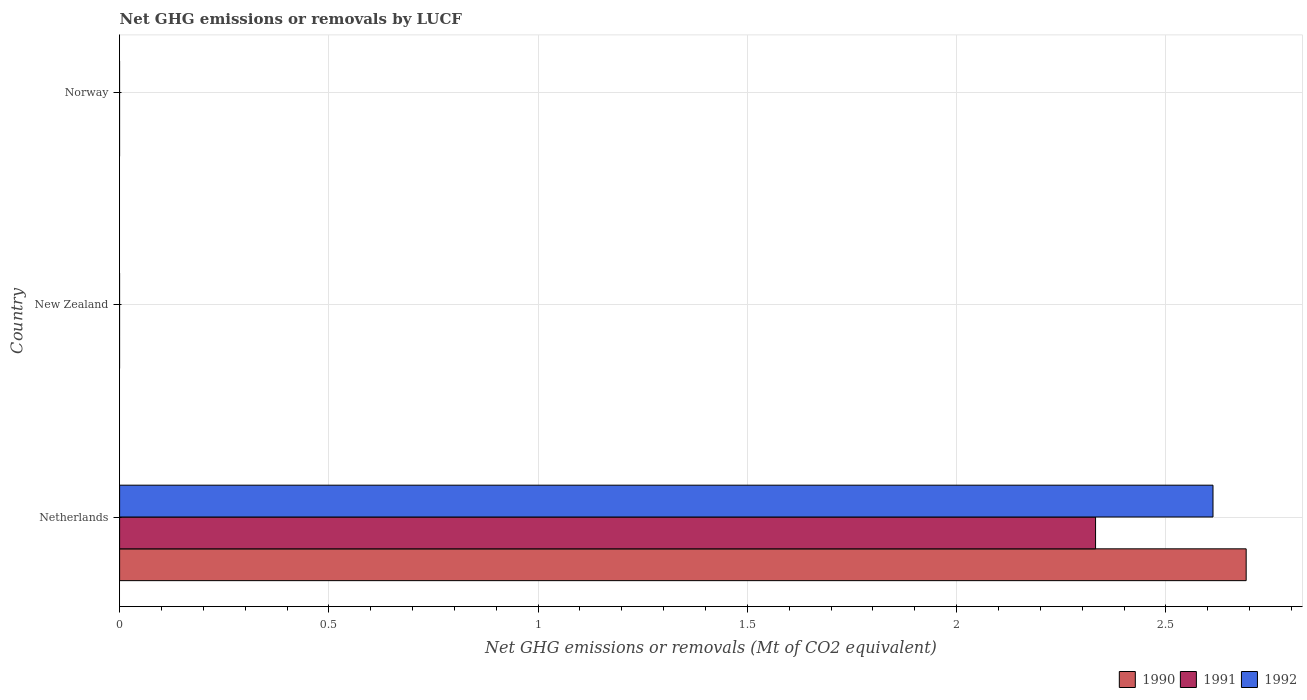Are the number of bars per tick equal to the number of legend labels?
Provide a succinct answer. No. Are the number of bars on each tick of the Y-axis equal?
Ensure brevity in your answer.  No. What is the label of the 2nd group of bars from the top?
Your response must be concise. New Zealand. Across all countries, what is the maximum net GHG emissions or removals by LUCF in 1991?
Offer a terse response. 2.33. Across all countries, what is the minimum net GHG emissions or removals by LUCF in 1991?
Provide a short and direct response. 0. What is the total net GHG emissions or removals by LUCF in 1992 in the graph?
Make the answer very short. 2.61. What is the difference between the net GHG emissions or removals by LUCF in 1992 in Netherlands and the net GHG emissions or removals by LUCF in 1990 in Norway?
Make the answer very short. 2.61. What is the average net GHG emissions or removals by LUCF in 1992 per country?
Ensure brevity in your answer.  0.87. What is the difference between the net GHG emissions or removals by LUCF in 1991 and net GHG emissions or removals by LUCF in 1990 in Netherlands?
Keep it short and to the point. -0.36. What is the difference between the highest and the lowest net GHG emissions or removals by LUCF in 1992?
Your response must be concise. 2.61. In how many countries, is the net GHG emissions or removals by LUCF in 1990 greater than the average net GHG emissions or removals by LUCF in 1990 taken over all countries?
Your answer should be compact. 1. How many bars are there?
Provide a succinct answer. 3. Are all the bars in the graph horizontal?
Provide a succinct answer. Yes. How many countries are there in the graph?
Your answer should be very brief. 3. What is the difference between two consecutive major ticks on the X-axis?
Ensure brevity in your answer.  0.5. Does the graph contain any zero values?
Your answer should be very brief. Yes. Where does the legend appear in the graph?
Provide a succinct answer. Bottom right. How many legend labels are there?
Offer a terse response. 3. How are the legend labels stacked?
Your answer should be very brief. Horizontal. What is the title of the graph?
Ensure brevity in your answer.  Net GHG emissions or removals by LUCF. What is the label or title of the X-axis?
Offer a terse response. Net GHG emissions or removals (Mt of CO2 equivalent). What is the Net GHG emissions or removals (Mt of CO2 equivalent) in 1990 in Netherlands?
Your answer should be very brief. 2.69. What is the Net GHG emissions or removals (Mt of CO2 equivalent) of 1991 in Netherlands?
Your response must be concise. 2.33. What is the Net GHG emissions or removals (Mt of CO2 equivalent) of 1992 in Netherlands?
Make the answer very short. 2.61. What is the Net GHG emissions or removals (Mt of CO2 equivalent) in 1990 in New Zealand?
Give a very brief answer. 0. What is the Net GHG emissions or removals (Mt of CO2 equivalent) of 1991 in New Zealand?
Give a very brief answer. 0. What is the Net GHG emissions or removals (Mt of CO2 equivalent) in 1992 in New Zealand?
Provide a short and direct response. 0. What is the Net GHG emissions or removals (Mt of CO2 equivalent) in 1991 in Norway?
Make the answer very short. 0. Across all countries, what is the maximum Net GHG emissions or removals (Mt of CO2 equivalent) in 1990?
Your answer should be compact. 2.69. Across all countries, what is the maximum Net GHG emissions or removals (Mt of CO2 equivalent) of 1991?
Offer a very short reply. 2.33. Across all countries, what is the maximum Net GHG emissions or removals (Mt of CO2 equivalent) of 1992?
Make the answer very short. 2.61. Across all countries, what is the minimum Net GHG emissions or removals (Mt of CO2 equivalent) in 1991?
Your answer should be very brief. 0. Across all countries, what is the minimum Net GHG emissions or removals (Mt of CO2 equivalent) in 1992?
Provide a short and direct response. 0. What is the total Net GHG emissions or removals (Mt of CO2 equivalent) of 1990 in the graph?
Offer a very short reply. 2.69. What is the total Net GHG emissions or removals (Mt of CO2 equivalent) of 1991 in the graph?
Give a very brief answer. 2.33. What is the total Net GHG emissions or removals (Mt of CO2 equivalent) of 1992 in the graph?
Offer a very short reply. 2.61. What is the average Net GHG emissions or removals (Mt of CO2 equivalent) of 1990 per country?
Ensure brevity in your answer.  0.9. What is the average Net GHG emissions or removals (Mt of CO2 equivalent) of 1991 per country?
Your response must be concise. 0.78. What is the average Net GHG emissions or removals (Mt of CO2 equivalent) in 1992 per country?
Provide a succinct answer. 0.87. What is the difference between the Net GHG emissions or removals (Mt of CO2 equivalent) in 1990 and Net GHG emissions or removals (Mt of CO2 equivalent) in 1991 in Netherlands?
Your answer should be very brief. 0.36. What is the difference between the Net GHG emissions or removals (Mt of CO2 equivalent) in 1990 and Net GHG emissions or removals (Mt of CO2 equivalent) in 1992 in Netherlands?
Offer a very short reply. 0.08. What is the difference between the Net GHG emissions or removals (Mt of CO2 equivalent) of 1991 and Net GHG emissions or removals (Mt of CO2 equivalent) of 1992 in Netherlands?
Ensure brevity in your answer.  -0.28. What is the difference between the highest and the lowest Net GHG emissions or removals (Mt of CO2 equivalent) of 1990?
Provide a short and direct response. 2.69. What is the difference between the highest and the lowest Net GHG emissions or removals (Mt of CO2 equivalent) of 1991?
Keep it short and to the point. 2.33. What is the difference between the highest and the lowest Net GHG emissions or removals (Mt of CO2 equivalent) in 1992?
Offer a terse response. 2.61. 